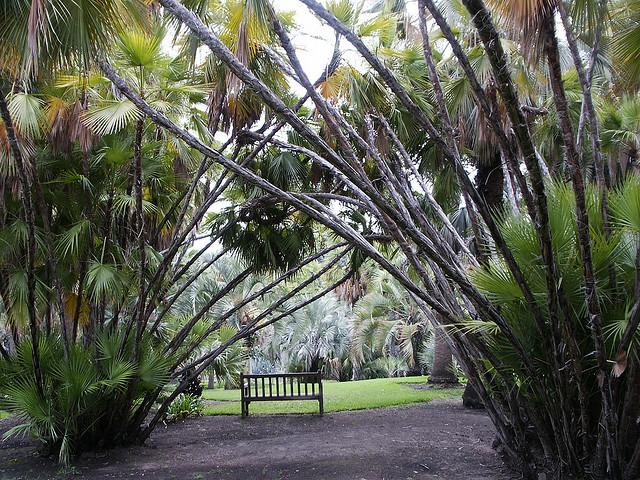Is the grass lush?
Keep it brief. Yes. Who is at the bench?
Write a very short answer. No one. Is it raining?
Give a very brief answer. No. Is this plant edible?
Answer briefly. No. 